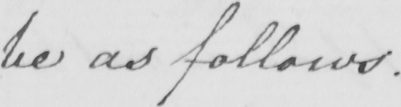What does this handwritten line say? be as follows . 